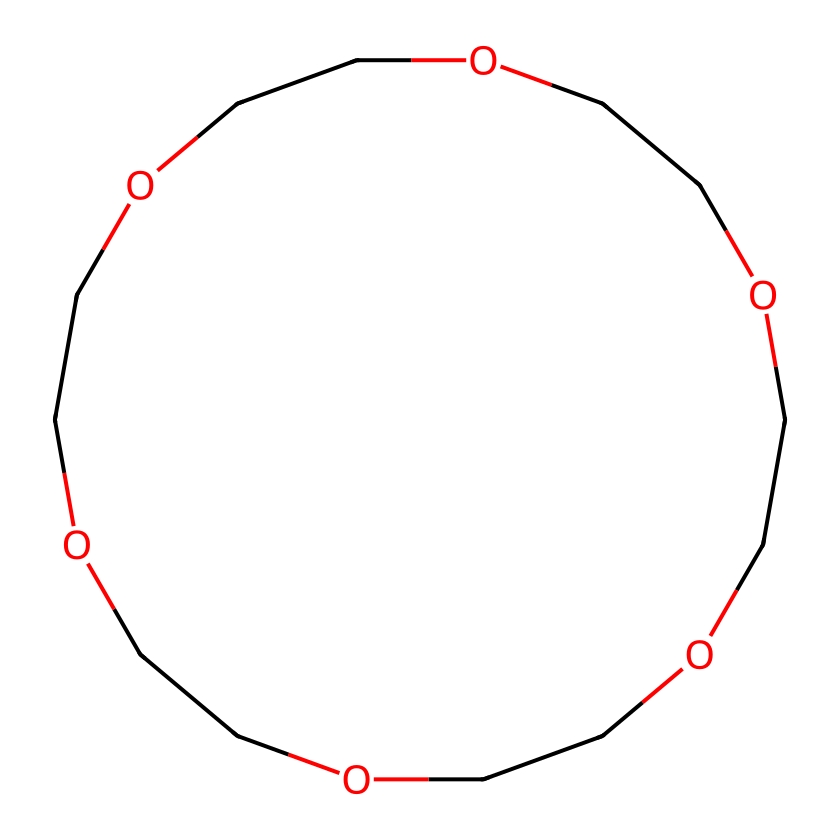What is the molecular formula of this ether? By analyzing the SMILES representation, we identify the atoms present: each "C" represents a carbon atom, and each "O" represents an oxygen atom. Counting them gives us 6 carbon atoms and 6 oxygen atoms. The molecular formula is formed by combining these totals, which results in C6H12O6.
Answer: C6H12O6 How many oxygen atoms are in the structure? In the given SMILES representation, there are 6 instances of "O", signifying the presence of 6 oxygen atoms in the molecule.
Answer: 6 What type of linkage connects the ether units? Looking at the structure, the "C" and "O" atoms alternating indicate that it has an ether linkage, where the oxygen is bonded to two alkyl or aryl groups. Each ether unit connects to the next via these oxygen atoms.
Answer: ether What is the shape of the molecular structure based on this arrangement? The arrangement of alternating carbon and oxygen atoms suggests a cyclic structure due to the closing "C1" and "C" at the end of the chain, forming a ring that exhibits a crown-like shape.
Answer: crown How does the molecular arrangement contribute to ion detection? The oxygen atoms in the crown ether structure create voids where metal ions can be encapsulated. This selective encapsulation allows the molecule to effectively detect and bind with specific ions, facilitating environmental cleanup processes.
Answer: encapsulation What is the primary application of this compound? The cyclic arrangement and the nature of the ether provide it with the ability to encapsulate ions, making crown ethers widely used for ion transportation, extraction, and environmental remediation, especially in detecting and removing heavy metals.
Answer: ion detection 